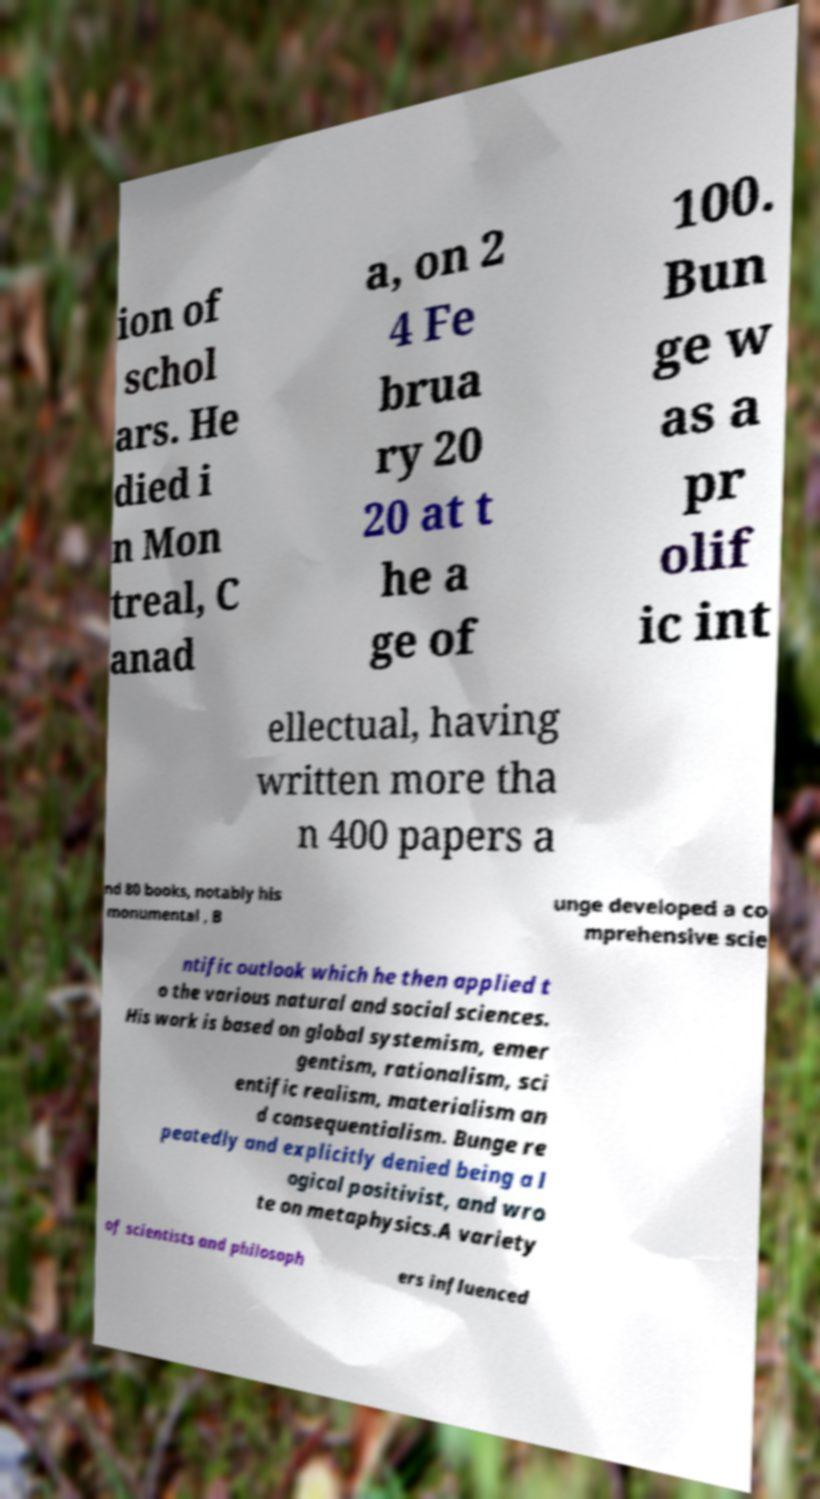I need the written content from this picture converted into text. Can you do that? ion of schol ars. He died i n Mon treal, C anad a, on 2 4 Fe brua ry 20 20 at t he a ge of 100. Bun ge w as a pr olif ic int ellectual, having written more tha n 400 papers a nd 80 books, notably his monumental , B unge developed a co mprehensive scie ntific outlook which he then applied t o the various natural and social sciences. His work is based on global systemism, emer gentism, rationalism, sci entific realism, materialism an d consequentialism. Bunge re peatedly and explicitly denied being a l ogical positivist, and wro te on metaphysics.A variety of scientists and philosoph ers influenced 